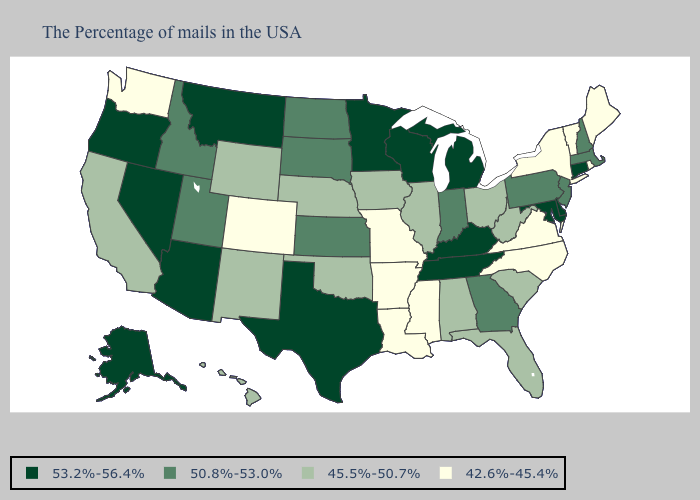What is the value of Kentucky?
Short answer required. 53.2%-56.4%. What is the highest value in the USA?
Be succinct. 53.2%-56.4%. Does the map have missing data?
Be succinct. No. Does Oregon have the highest value in the West?
Be succinct. Yes. Among the states that border Wisconsin , which have the highest value?
Quick response, please. Michigan, Minnesota. Does Illinois have the same value as Oklahoma?
Short answer required. Yes. Is the legend a continuous bar?
Short answer required. No. Name the states that have a value in the range 50.8%-53.0%?
Answer briefly. Massachusetts, New Hampshire, New Jersey, Pennsylvania, Georgia, Indiana, Kansas, South Dakota, North Dakota, Utah, Idaho. What is the value of Minnesota?
Concise answer only. 53.2%-56.4%. Name the states that have a value in the range 50.8%-53.0%?
Quick response, please. Massachusetts, New Hampshire, New Jersey, Pennsylvania, Georgia, Indiana, Kansas, South Dakota, North Dakota, Utah, Idaho. Does the first symbol in the legend represent the smallest category?
Quick response, please. No. Among the states that border Oregon , which have the highest value?
Concise answer only. Nevada. Does Colorado have the highest value in the USA?
Be succinct. No. What is the value of Arizona?
Concise answer only. 53.2%-56.4%. What is the value of Utah?
Concise answer only. 50.8%-53.0%. 